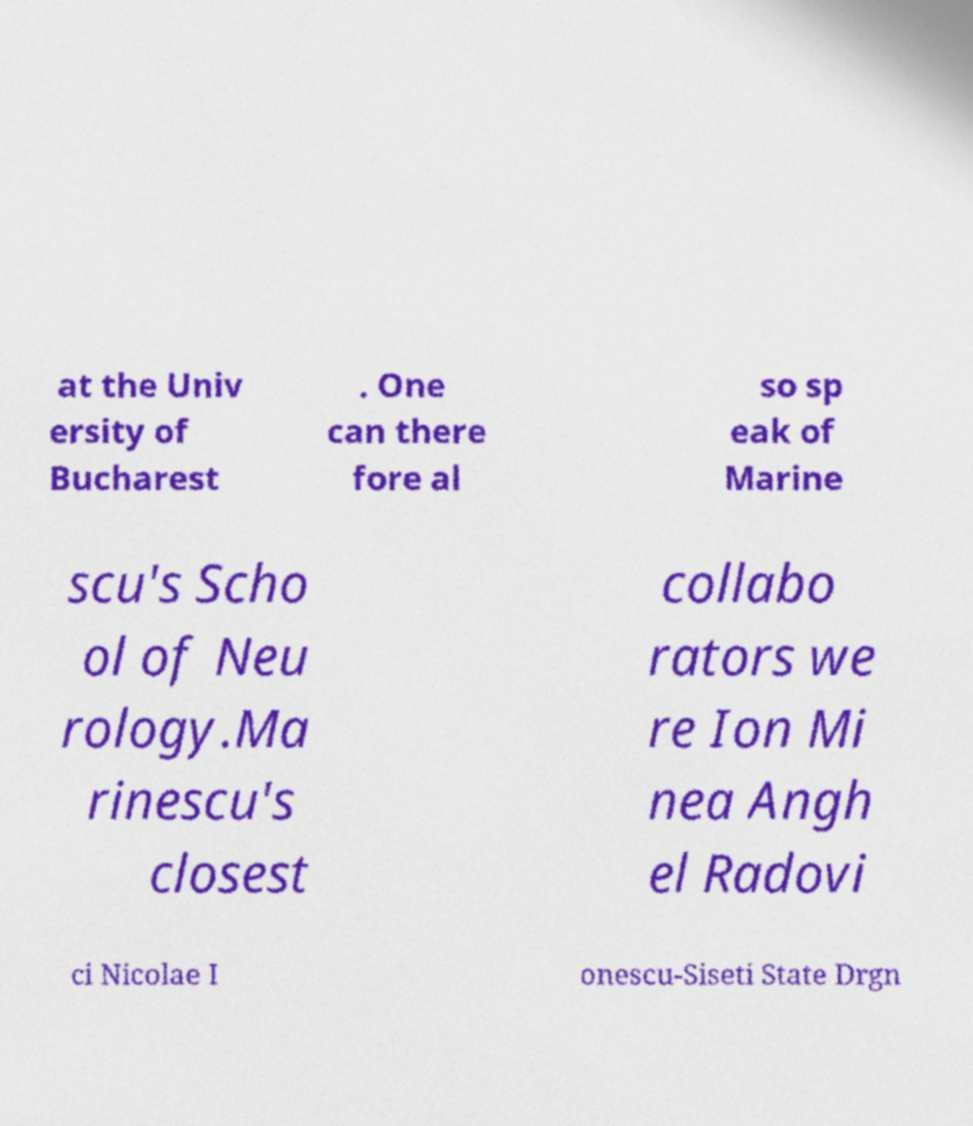For documentation purposes, I need the text within this image transcribed. Could you provide that? at the Univ ersity of Bucharest . One can there fore al so sp eak of Marine scu's Scho ol of Neu rology.Ma rinescu's closest collabo rators we re Ion Mi nea Angh el Radovi ci Nicolae I onescu-Siseti State Drgn 